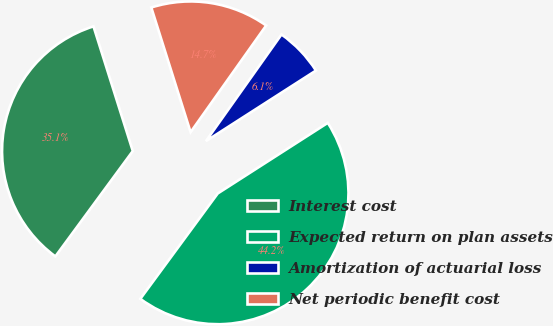<chart> <loc_0><loc_0><loc_500><loc_500><pie_chart><fcel>Interest cost<fcel>Expected return on plan assets<fcel>Amortization of actuarial loss<fcel>Net periodic benefit cost<nl><fcel>35.05%<fcel>44.16%<fcel>6.11%<fcel>14.67%<nl></chart> 